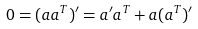Convert formula to latex. <formula><loc_0><loc_0><loc_500><loc_500>0 = ( a a ^ { T } ) ^ { \prime } = a ^ { \prime } a ^ { T } + a ( a ^ { T } ) ^ { \prime }</formula> 